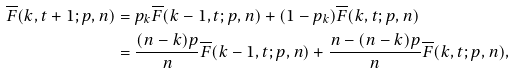<formula> <loc_0><loc_0><loc_500><loc_500>\overline { F } ( k , t + 1 ; p , n ) & = p _ { k } \overline { F } ( k - 1 , t ; p , n ) + ( 1 - p _ { k } ) \overline { F } ( k , t ; p , n ) \\ & = \frac { ( n - k ) p } { n } \overline { F } ( k - 1 , t ; p , n ) + \frac { n - ( n - k ) p } { n } \overline { F } ( k , t ; p , n ) ,</formula> 